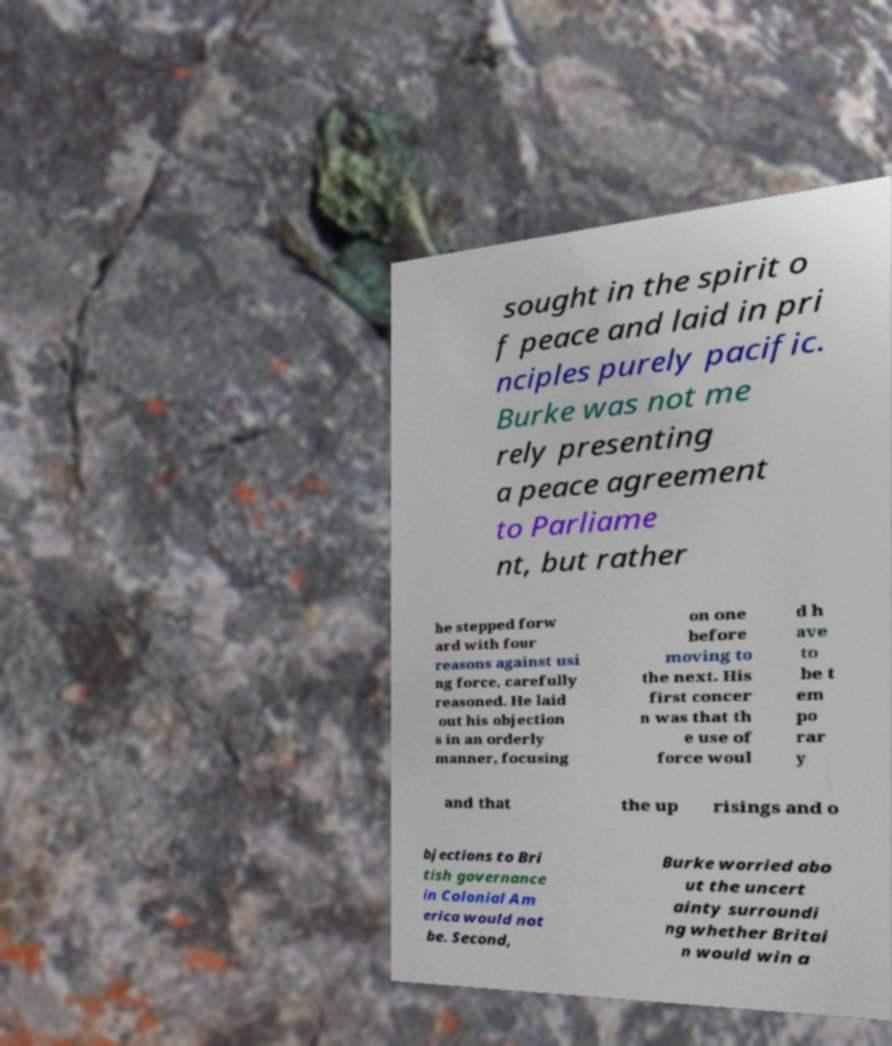Please read and relay the text visible in this image. What does it say? sought in the spirit o f peace and laid in pri nciples purely pacific. Burke was not me rely presenting a peace agreement to Parliame nt, but rather he stepped forw ard with four reasons against usi ng force, carefully reasoned. He laid out his objection s in an orderly manner, focusing on one before moving to the next. His first concer n was that th e use of force woul d h ave to be t em po rar y and that the up risings and o bjections to Bri tish governance in Colonial Am erica would not be. Second, Burke worried abo ut the uncert ainty surroundi ng whether Britai n would win a 